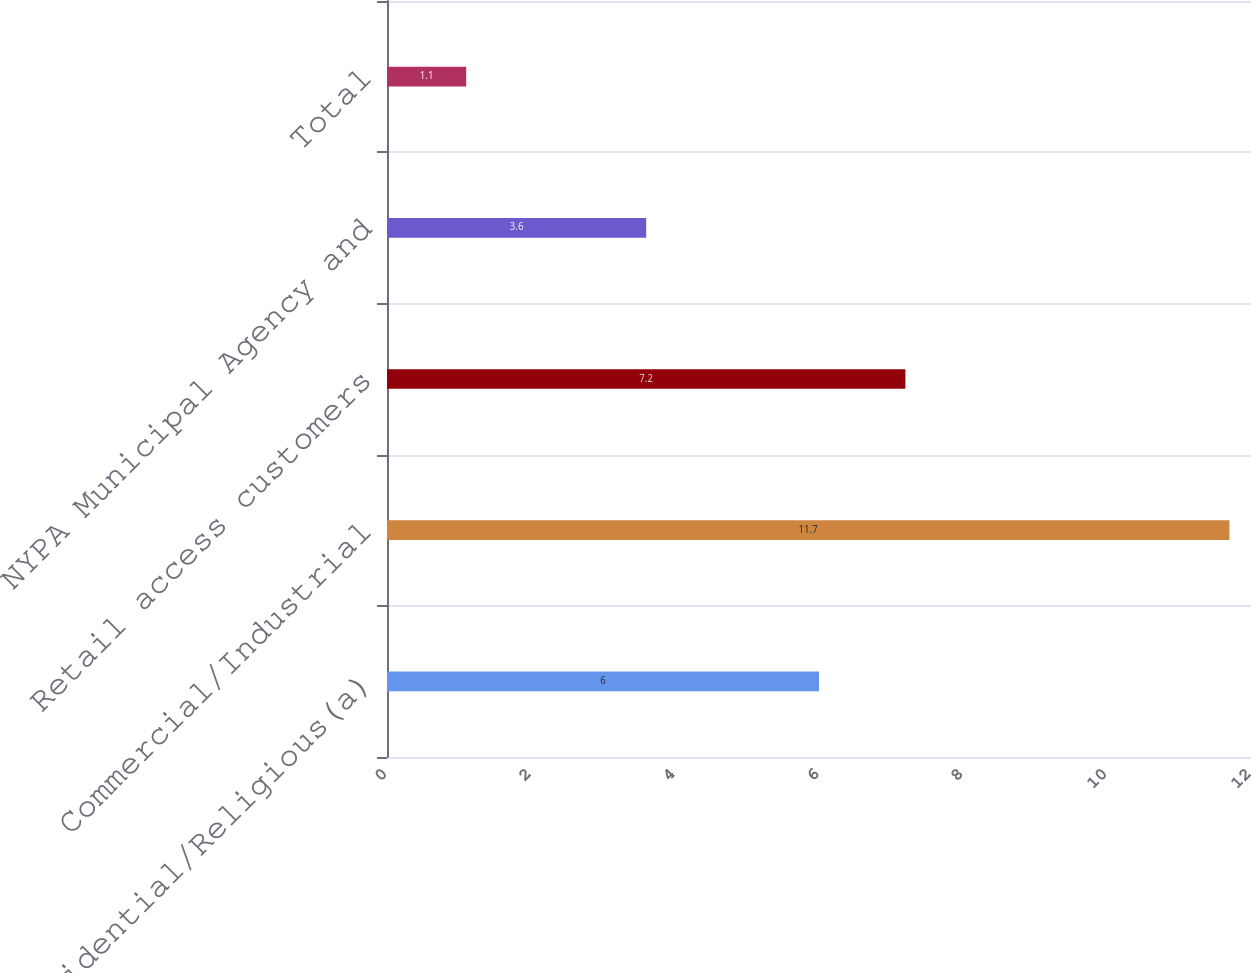Convert chart. <chart><loc_0><loc_0><loc_500><loc_500><bar_chart><fcel>Residential/Religious(a)<fcel>Commercial/Industrial<fcel>Retail access customers<fcel>NYPA Municipal Agency and<fcel>Total<nl><fcel>6<fcel>11.7<fcel>7.2<fcel>3.6<fcel>1.1<nl></chart> 